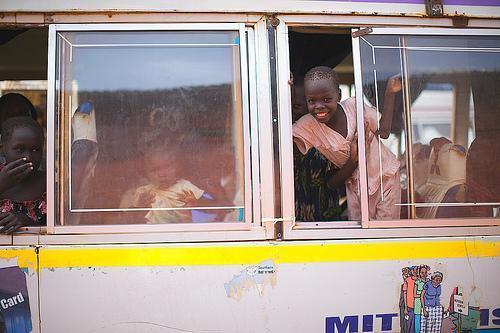How many people are holding the dog near the bus?
Give a very brief answer. 0. 